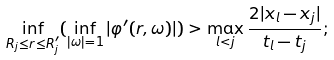<formula> <loc_0><loc_0><loc_500><loc_500>\inf _ { R _ { j } \leq r \leq R _ { j } ^ { \prime } } ( \inf _ { | \omega | = 1 } | \varphi ^ { \prime } ( r , \omega ) | ) > \max _ { l < j } \frac { 2 | x _ { l } - x _ { j } | } { t _ { l } - t _ { j } } ;</formula> 